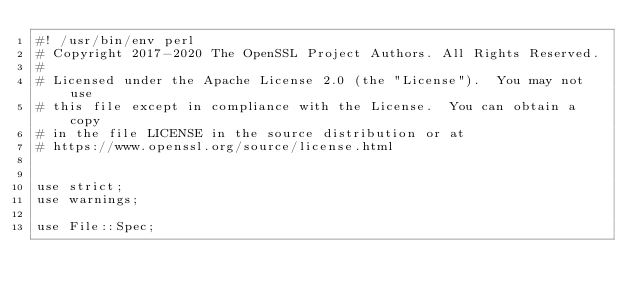Convert code to text. <code><loc_0><loc_0><loc_500><loc_500><_Perl_>#! /usr/bin/env perl
# Copyright 2017-2020 The OpenSSL Project Authors. All Rights Reserved.
#
# Licensed under the Apache License 2.0 (the "License").  You may not use
# this file except in compliance with the License.  You can obtain a copy
# in the file LICENSE in the source distribution or at
# https://www.openssl.org/source/license.html


use strict;
use warnings;

use File::Spec;</code> 